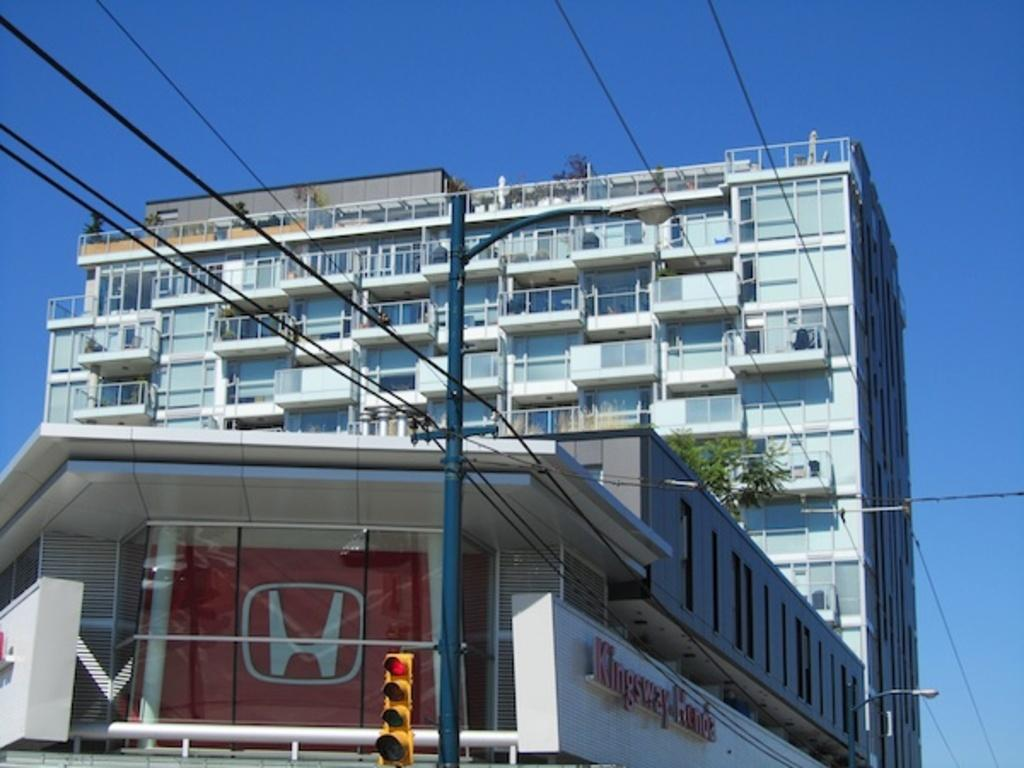What type of structure is visible in the image? There is a building with windows in the image. What can be seen near the building? There is a traffic light in the image. What object is present in the image that might display information or advertisements? There is a board in the image. What is attached to the pole in the image? There are wires on the pole in the image. What type of vegetation is present in the image? There is a plant in the image. What is visible in the background of the image? The sky is visible in the image. How many trucks are parked near the building in the image? There are no trucks present in the image. What type of brake system is installed on the traffic light in the image? There is no brake system present on the traffic light in the image; it is an electrical device for controlling traffic flow. 